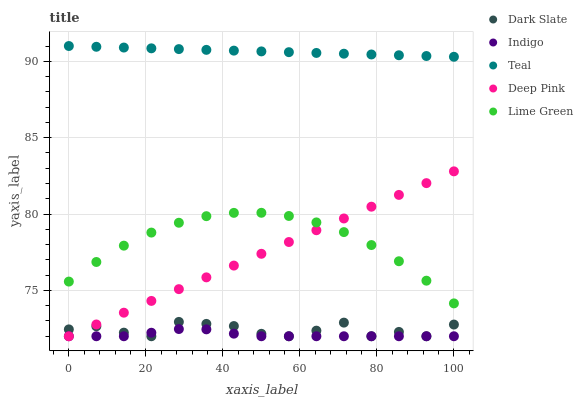Does Indigo have the minimum area under the curve?
Answer yes or no. Yes. Does Teal have the maximum area under the curve?
Answer yes or no. Yes. Does Dark Slate have the minimum area under the curve?
Answer yes or no. No. Does Dark Slate have the maximum area under the curve?
Answer yes or no. No. Is Deep Pink the smoothest?
Answer yes or no. Yes. Is Dark Slate the roughest?
Answer yes or no. Yes. Is Dark Slate the smoothest?
Answer yes or no. No. Is Deep Pink the roughest?
Answer yes or no. No. Does Dark Slate have the lowest value?
Answer yes or no. Yes. Does Teal have the lowest value?
Answer yes or no. No. Does Teal have the highest value?
Answer yes or no. Yes. Does Dark Slate have the highest value?
Answer yes or no. No. Is Dark Slate less than Teal?
Answer yes or no. Yes. Is Lime Green greater than Indigo?
Answer yes or no. Yes. Does Indigo intersect Deep Pink?
Answer yes or no. Yes. Is Indigo less than Deep Pink?
Answer yes or no. No. Is Indigo greater than Deep Pink?
Answer yes or no. No. Does Dark Slate intersect Teal?
Answer yes or no. No. 